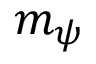<formula> <loc_0><loc_0><loc_500><loc_500>m _ { \psi }</formula> 